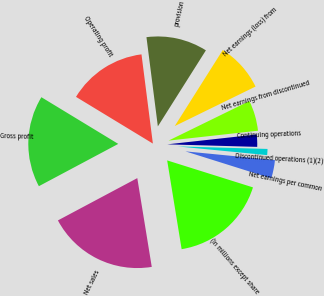Convert chart to OTSL. <chart><loc_0><loc_0><loc_500><loc_500><pie_chart><fcel>(In millions except share<fcel>Net sales<fcel>Gross profit<fcel>Operating profit<fcel>provision<fcel>Net earnings (loss) from<fcel>Net earnings from discontinued<fcel>Continuing operations<fcel>Discontinued operations (1)(2)<fcel>Net earnings per common<nl><fcel>17.58%<fcel>19.78%<fcel>16.48%<fcel>14.29%<fcel>10.99%<fcel>8.79%<fcel>5.49%<fcel>2.2%<fcel>1.1%<fcel>3.3%<nl></chart> 